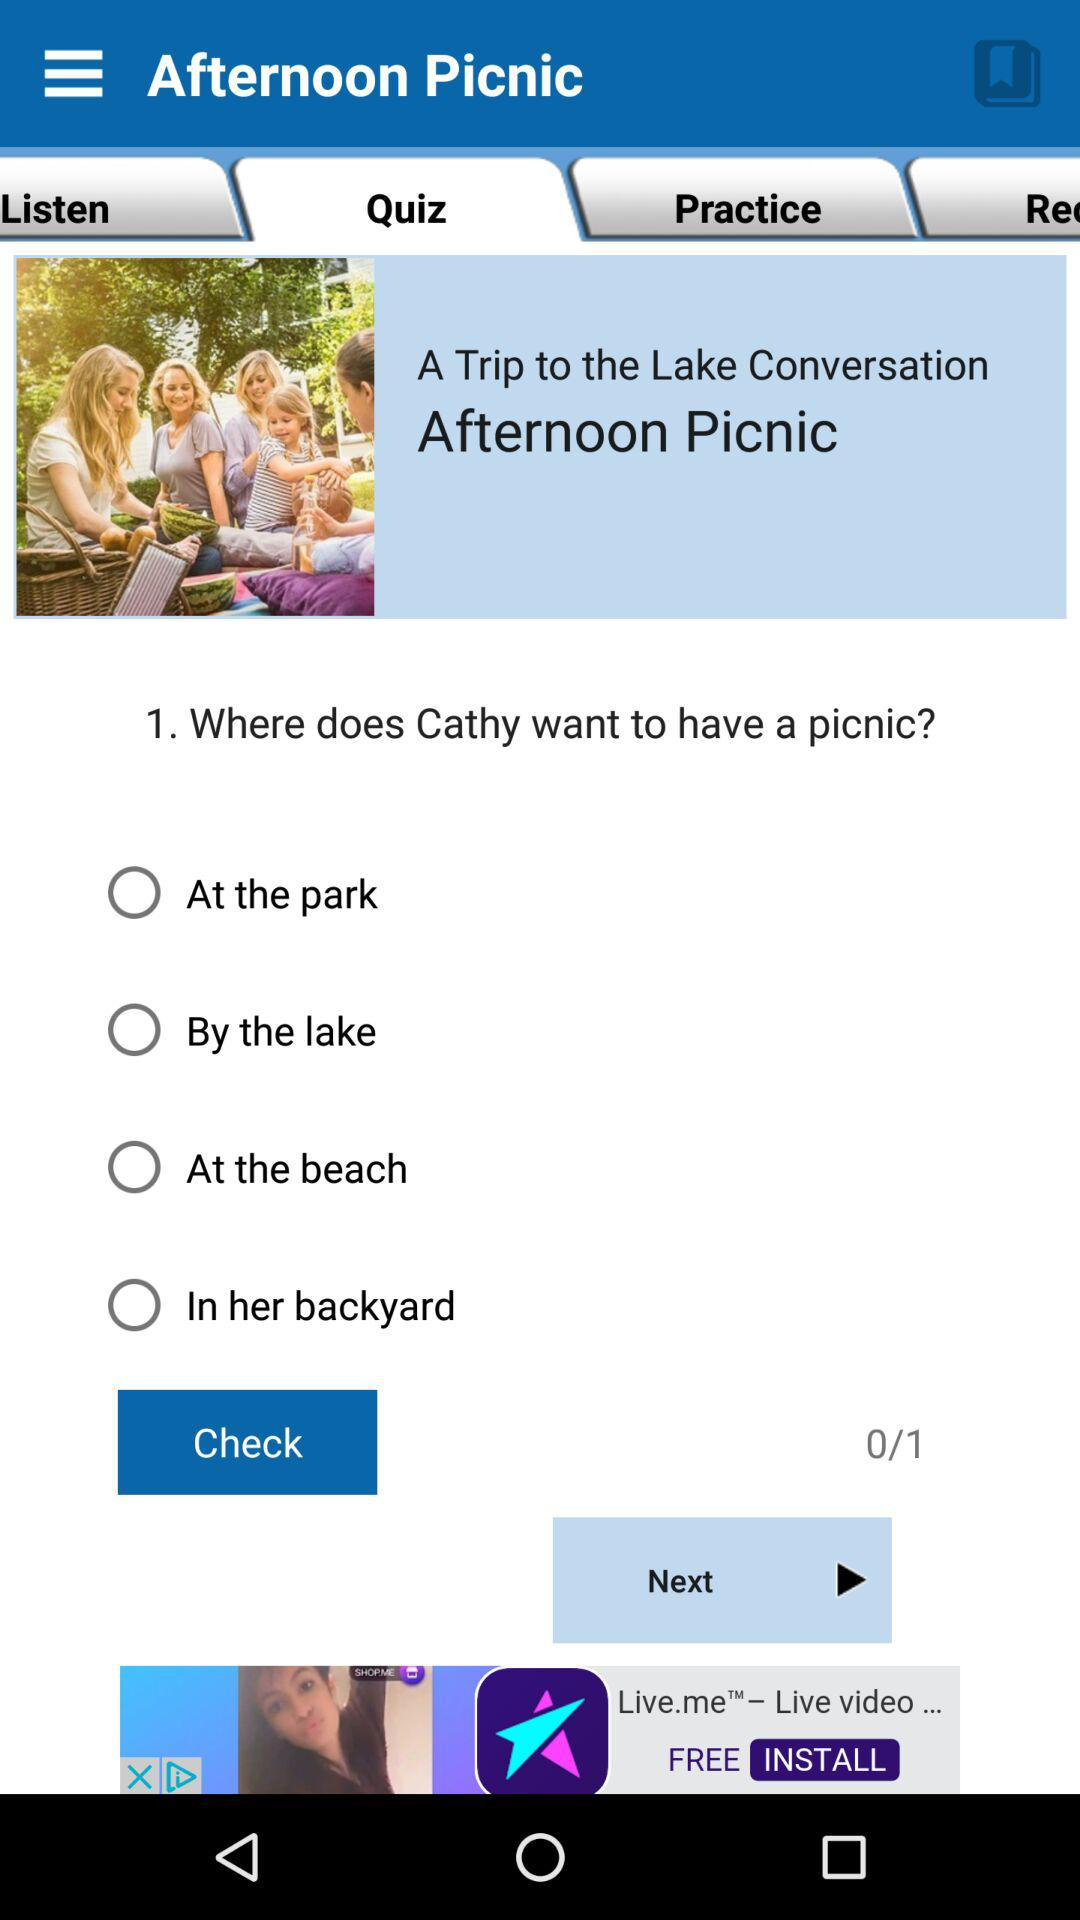What tab am I on? You are on the "Quiz" tab. 